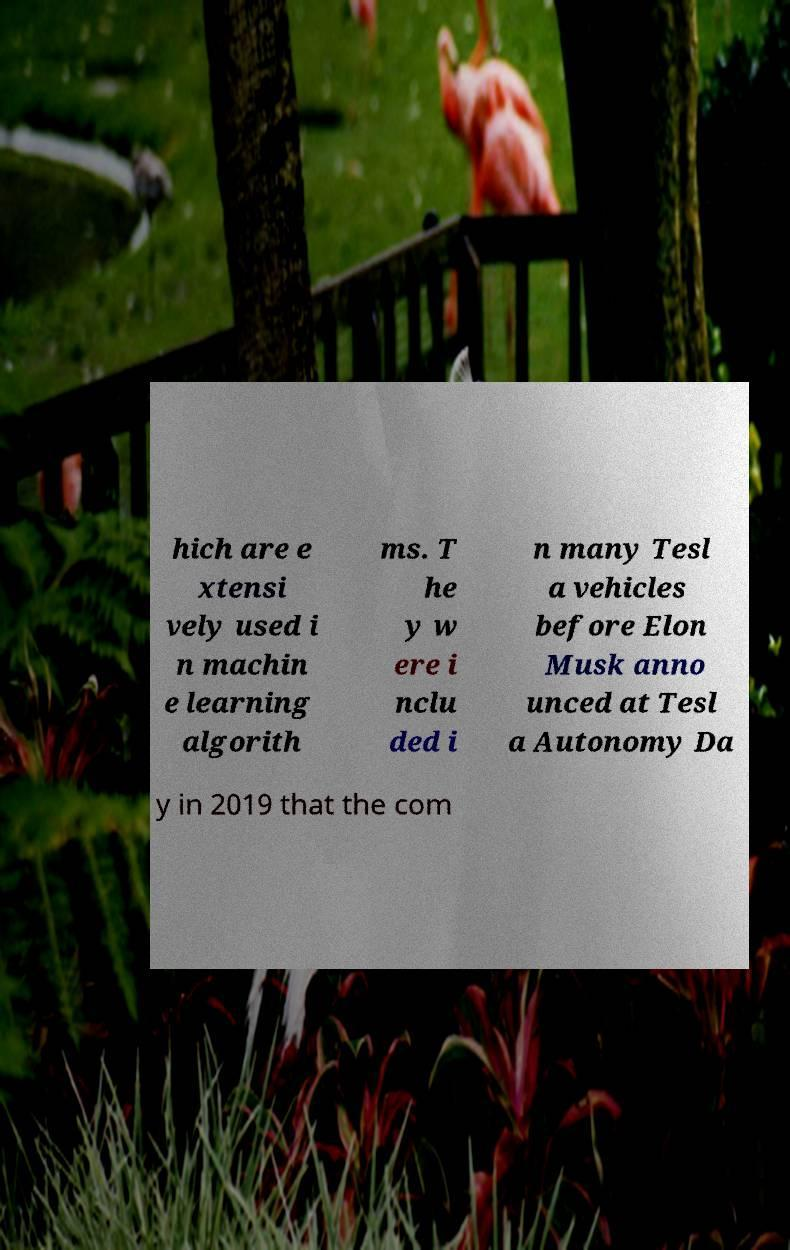Can you read and provide the text displayed in the image?This photo seems to have some interesting text. Can you extract and type it out for me? hich are e xtensi vely used i n machin e learning algorith ms. T he y w ere i nclu ded i n many Tesl a vehicles before Elon Musk anno unced at Tesl a Autonomy Da y in 2019 that the com 